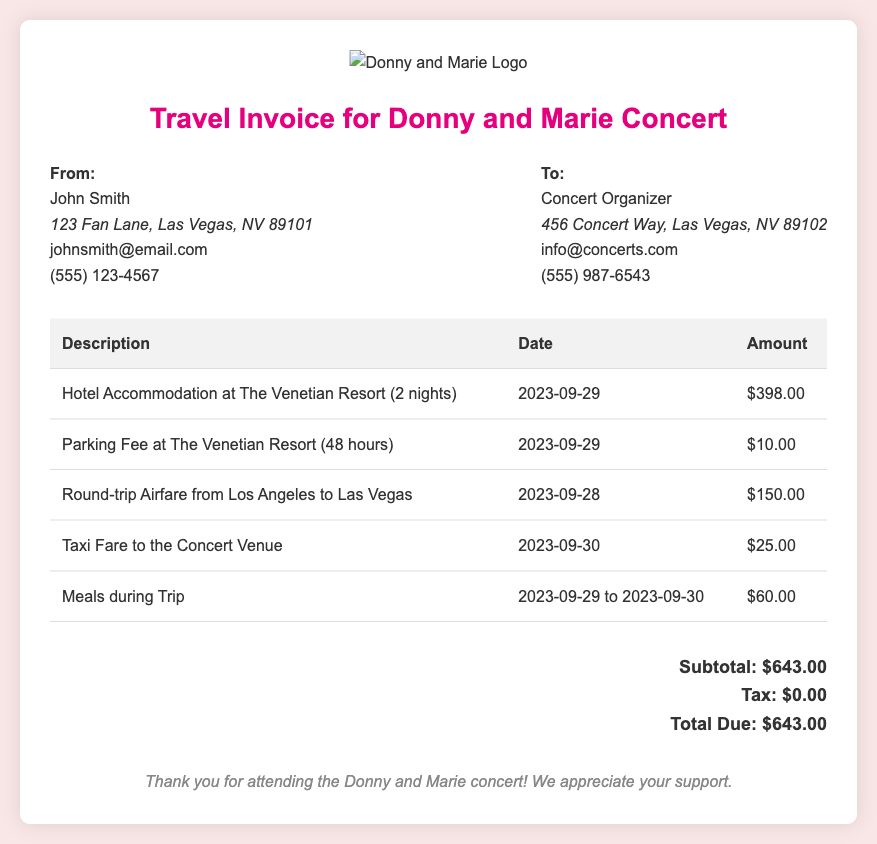What is the total due amount? The total due amount is specified in the document under 'Total Due', which includes subtotal and tax.
Answer: $643.00 What is the parking fee amount? The parking fee amount is listed in the itemized expenses of the document.
Answer: $10.00 How many nights did the hotel accommodation cover? The hotel accommodation details indicate the duration of stay.
Answer: 2 nights What is the date of the round-trip airfare? The date for the airfare is provided in the itemized table for transactions.
Answer: 2023-09-28 What type of expenses are included in the invoice? The document outlines various types of expenses related to travel for the concert.
Answer: Hotel, Parking, Airfare, Taxi, Meals What was the taxi fare to the concert venue? The amount for taxi fare is detailed in the expense list, providing a specific figure.
Answer: $25.00 What is the name of the hotel listed? The hotel name is mentioned alongside the accommodation details in the document.
Answer: The Venetian Resort What date did the concert trip occur? The concert trip dates can be inferred from the dated expenses listed in the document.
Answer: 2023-09-29 Who is the recipient of the invoice? The recipient's name is provided at the top section of the invoice document.
Answer: Concert Organizer 